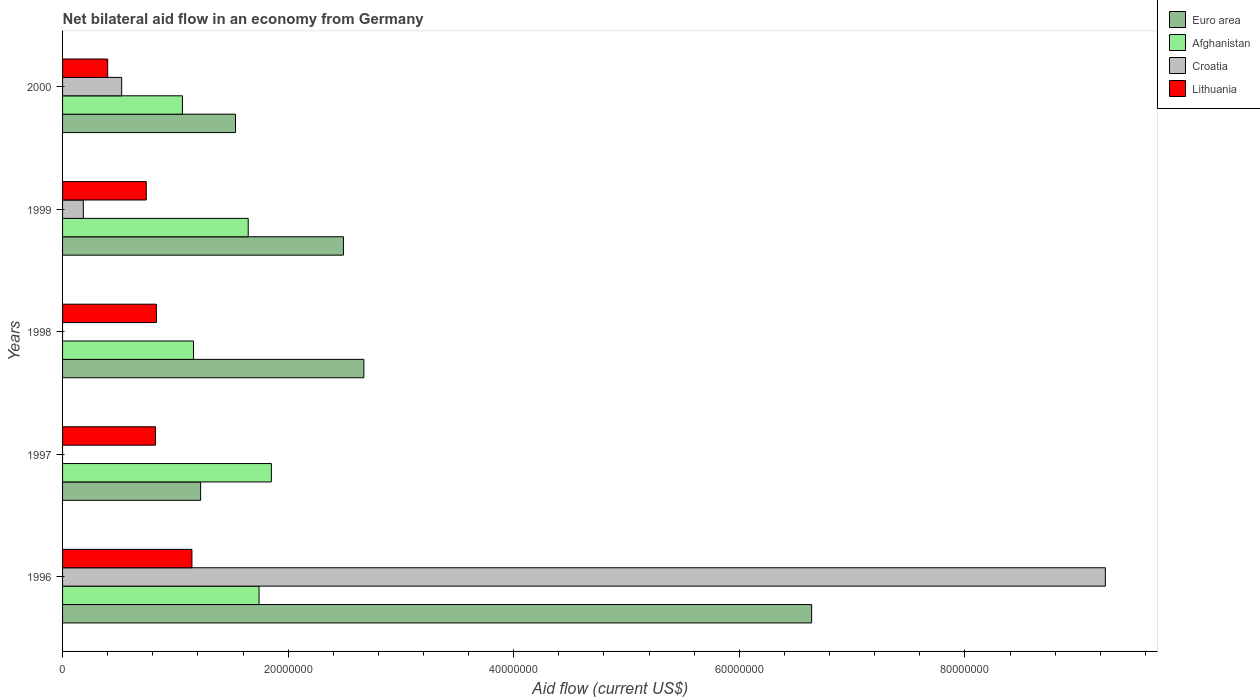How many groups of bars are there?
Offer a very short reply. 5. Are the number of bars per tick equal to the number of legend labels?
Provide a short and direct response. No. Are the number of bars on each tick of the Y-axis equal?
Your answer should be compact. No. How many bars are there on the 4th tick from the top?
Offer a terse response. 3. What is the label of the 5th group of bars from the top?
Keep it short and to the point. 1996. In how many cases, is the number of bars for a given year not equal to the number of legend labels?
Ensure brevity in your answer.  2. What is the net bilateral aid flow in Croatia in 2000?
Your answer should be very brief. 5.24e+06. Across all years, what is the maximum net bilateral aid flow in Afghanistan?
Offer a very short reply. 1.85e+07. Across all years, what is the minimum net bilateral aid flow in Euro area?
Provide a succinct answer. 1.22e+07. What is the total net bilateral aid flow in Afghanistan in the graph?
Provide a succinct answer. 7.46e+07. What is the difference between the net bilateral aid flow in Euro area in 1997 and that in 2000?
Provide a short and direct response. -3.09e+06. What is the difference between the net bilateral aid flow in Lithuania in 1996 and the net bilateral aid flow in Croatia in 1999?
Give a very brief answer. 9.63e+06. What is the average net bilateral aid flow in Afghanistan per year?
Your answer should be compact. 1.49e+07. In how many years, is the net bilateral aid flow in Afghanistan greater than 64000000 US$?
Offer a very short reply. 0. What is the ratio of the net bilateral aid flow in Lithuania in 1997 to that in 1998?
Your answer should be very brief. 0.99. What is the difference between the highest and the second highest net bilateral aid flow in Croatia?
Your answer should be compact. 8.72e+07. What is the difference between the highest and the lowest net bilateral aid flow in Afghanistan?
Your response must be concise. 7.88e+06. In how many years, is the net bilateral aid flow in Croatia greater than the average net bilateral aid flow in Croatia taken over all years?
Offer a terse response. 1. Is the sum of the net bilateral aid flow in Lithuania in 1998 and 2000 greater than the maximum net bilateral aid flow in Croatia across all years?
Give a very brief answer. No. Is it the case that in every year, the sum of the net bilateral aid flow in Euro area and net bilateral aid flow in Lithuania is greater than the net bilateral aid flow in Afghanistan?
Your answer should be compact. Yes. Are all the bars in the graph horizontal?
Offer a very short reply. Yes. How many years are there in the graph?
Your response must be concise. 5. Does the graph contain any zero values?
Provide a succinct answer. Yes. Does the graph contain grids?
Offer a very short reply. No. What is the title of the graph?
Give a very brief answer. Net bilateral aid flow in an economy from Germany. Does "Sub-Saharan Africa (developing only)" appear as one of the legend labels in the graph?
Provide a succinct answer. No. What is the Aid flow (current US$) of Euro area in 1996?
Your response must be concise. 6.64e+07. What is the Aid flow (current US$) of Afghanistan in 1996?
Give a very brief answer. 1.74e+07. What is the Aid flow (current US$) of Croatia in 1996?
Provide a succinct answer. 9.24e+07. What is the Aid flow (current US$) in Lithuania in 1996?
Make the answer very short. 1.15e+07. What is the Aid flow (current US$) of Euro area in 1997?
Your answer should be compact. 1.22e+07. What is the Aid flow (current US$) in Afghanistan in 1997?
Your answer should be compact. 1.85e+07. What is the Aid flow (current US$) of Lithuania in 1997?
Give a very brief answer. 8.24e+06. What is the Aid flow (current US$) in Euro area in 1998?
Offer a terse response. 2.67e+07. What is the Aid flow (current US$) in Afghanistan in 1998?
Your answer should be compact. 1.16e+07. What is the Aid flow (current US$) in Lithuania in 1998?
Your answer should be compact. 8.32e+06. What is the Aid flow (current US$) in Euro area in 1999?
Ensure brevity in your answer.  2.49e+07. What is the Aid flow (current US$) of Afghanistan in 1999?
Keep it short and to the point. 1.65e+07. What is the Aid flow (current US$) in Croatia in 1999?
Provide a succinct answer. 1.84e+06. What is the Aid flow (current US$) of Lithuania in 1999?
Provide a succinct answer. 7.42e+06. What is the Aid flow (current US$) in Euro area in 2000?
Ensure brevity in your answer.  1.53e+07. What is the Aid flow (current US$) in Afghanistan in 2000?
Provide a short and direct response. 1.06e+07. What is the Aid flow (current US$) in Croatia in 2000?
Your response must be concise. 5.24e+06. What is the Aid flow (current US$) in Lithuania in 2000?
Provide a succinct answer. 4.00e+06. Across all years, what is the maximum Aid flow (current US$) in Euro area?
Offer a very short reply. 6.64e+07. Across all years, what is the maximum Aid flow (current US$) of Afghanistan?
Provide a short and direct response. 1.85e+07. Across all years, what is the maximum Aid flow (current US$) of Croatia?
Offer a terse response. 9.24e+07. Across all years, what is the maximum Aid flow (current US$) in Lithuania?
Make the answer very short. 1.15e+07. Across all years, what is the minimum Aid flow (current US$) of Euro area?
Provide a short and direct response. 1.22e+07. Across all years, what is the minimum Aid flow (current US$) in Afghanistan?
Your response must be concise. 1.06e+07. Across all years, what is the minimum Aid flow (current US$) in Croatia?
Make the answer very short. 0. What is the total Aid flow (current US$) of Euro area in the graph?
Your response must be concise. 1.46e+08. What is the total Aid flow (current US$) of Afghanistan in the graph?
Give a very brief answer. 7.46e+07. What is the total Aid flow (current US$) in Croatia in the graph?
Provide a succinct answer. 9.95e+07. What is the total Aid flow (current US$) in Lithuania in the graph?
Keep it short and to the point. 3.94e+07. What is the difference between the Aid flow (current US$) of Euro area in 1996 and that in 1997?
Provide a short and direct response. 5.42e+07. What is the difference between the Aid flow (current US$) in Afghanistan in 1996 and that in 1997?
Keep it short and to the point. -1.09e+06. What is the difference between the Aid flow (current US$) of Lithuania in 1996 and that in 1997?
Ensure brevity in your answer.  3.23e+06. What is the difference between the Aid flow (current US$) of Euro area in 1996 and that in 1998?
Keep it short and to the point. 3.97e+07. What is the difference between the Aid flow (current US$) in Afghanistan in 1996 and that in 1998?
Your answer should be compact. 5.81e+06. What is the difference between the Aid flow (current US$) of Lithuania in 1996 and that in 1998?
Make the answer very short. 3.15e+06. What is the difference between the Aid flow (current US$) in Euro area in 1996 and that in 1999?
Offer a terse response. 4.15e+07. What is the difference between the Aid flow (current US$) in Afghanistan in 1996 and that in 1999?
Ensure brevity in your answer.  9.60e+05. What is the difference between the Aid flow (current US$) of Croatia in 1996 and that in 1999?
Your response must be concise. 9.06e+07. What is the difference between the Aid flow (current US$) in Lithuania in 1996 and that in 1999?
Give a very brief answer. 4.05e+06. What is the difference between the Aid flow (current US$) of Euro area in 1996 and that in 2000?
Keep it short and to the point. 5.11e+07. What is the difference between the Aid flow (current US$) of Afghanistan in 1996 and that in 2000?
Your response must be concise. 6.79e+06. What is the difference between the Aid flow (current US$) of Croatia in 1996 and that in 2000?
Your answer should be compact. 8.72e+07. What is the difference between the Aid flow (current US$) in Lithuania in 1996 and that in 2000?
Ensure brevity in your answer.  7.47e+06. What is the difference between the Aid flow (current US$) in Euro area in 1997 and that in 1998?
Offer a very short reply. -1.45e+07. What is the difference between the Aid flow (current US$) in Afghanistan in 1997 and that in 1998?
Make the answer very short. 6.90e+06. What is the difference between the Aid flow (current US$) in Lithuania in 1997 and that in 1998?
Ensure brevity in your answer.  -8.00e+04. What is the difference between the Aid flow (current US$) in Euro area in 1997 and that in 1999?
Provide a short and direct response. -1.27e+07. What is the difference between the Aid flow (current US$) of Afghanistan in 1997 and that in 1999?
Ensure brevity in your answer.  2.05e+06. What is the difference between the Aid flow (current US$) of Lithuania in 1997 and that in 1999?
Ensure brevity in your answer.  8.20e+05. What is the difference between the Aid flow (current US$) of Euro area in 1997 and that in 2000?
Offer a very short reply. -3.09e+06. What is the difference between the Aid flow (current US$) of Afghanistan in 1997 and that in 2000?
Keep it short and to the point. 7.88e+06. What is the difference between the Aid flow (current US$) in Lithuania in 1997 and that in 2000?
Ensure brevity in your answer.  4.24e+06. What is the difference between the Aid flow (current US$) in Euro area in 1998 and that in 1999?
Your response must be concise. 1.81e+06. What is the difference between the Aid flow (current US$) in Afghanistan in 1998 and that in 1999?
Your response must be concise. -4.85e+06. What is the difference between the Aid flow (current US$) of Euro area in 1998 and that in 2000?
Your answer should be compact. 1.14e+07. What is the difference between the Aid flow (current US$) in Afghanistan in 1998 and that in 2000?
Offer a very short reply. 9.80e+05. What is the difference between the Aid flow (current US$) in Lithuania in 1998 and that in 2000?
Make the answer very short. 4.32e+06. What is the difference between the Aid flow (current US$) of Euro area in 1999 and that in 2000?
Your response must be concise. 9.57e+06. What is the difference between the Aid flow (current US$) in Afghanistan in 1999 and that in 2000?
Your answer should be compact. 5.83e+06. What is the difference between the Aid flow (current US$) of Croatia in 1999 and that in 2000?
Make the answer very short. -3.40e+06. What is the difference between the Aid flow (current US$) of Lithuania in 1999 and that in 2000?
Your answer should be compact. 3.42e+06. What is the difference between the Aid flow (current US$) of Euro area in 1996 and the Aid flow (current US$) of Afghanistan in 1997?
Offer a very short reply. 4.79e+07. What is the difference between the Aid flow (current US$) of Euro area in 1996 and the Aid flow (current US$) of Lithuania in 1997?
Offer a terse response. 5.82e+07. What is the difference between the Aid flow (current US$) of Afghanistan in 1996 and the Aid flow (current US$) of Lithuania in 1997?
Your answer should be compact. 9.18e+06. What is the difference between the Aid flow (current US$) in Croatia in 1996 and the Aid flow (current US$) in Lithuania in 1997?
Keep it short and to the point. 8.42e+07. What is the difference between the Aid flow (current US$) in Euro area in 1996 and the Aid flow (current US$) in Afghanistan in 1998?
Offer a very short reply. 5.48e+07. What is the difference between the Aid flow (current US$) in Euro area in 1996 and the Aid flow (current US$) in Lithuania in 1998?
Provide a short and direct response. 5.81e+07. What is the difference between the Aid flow (current US$) in Afghanistan in 1996 and the Aid flow (current US$) in Lithuania in 1998?
Your answer should be very brief. 9.10e+06. What is the difference between the Aid flow (current US$) in Croatia in 1996 and the Aid flow (current US$) in Lithuania in 1998?
Offer a very short reply. 8.41e+07. What is the difference between the Aid flow (current US$) in Euro area in 1996 and the Aid flow (current US$) in Afghanistan in 1999?
Provide a succinct answer. 5.00e+07. What is the difference between the Aid flow (current US$) in Euro area in 1996 and the Aid flow (current US$) in Croatia in 1999?
Offer a very short reply. 6.46e+07. What is the difference between the Aid flow (current US$) in Euro area in 1996 and the Aid flow (current US$) in Lithuania in 1999?
Your response must be concise. 5.90e+07. What is the difference between the Aid flow (current US$) of Afghanistan in 1996 and the Aid flow (current US$) of Croatia in 1999?
Your answer should be very brief. 1.56e+07. What is the difference between the Aid flow (current US$) of Afghanistan in 1996 and the Aid flow (current US$) of Lithuania in 1999?
Ensure brevity in your answer.  1.00e+07. What is the difference between the Aid flow (current US$) of Croatia in 1996 and the Aid flow (current US$) of Lithuania in 1999?
Your answer should be compact. 8.50e+07. What is the difference between the Aid flow (current US$) of Euro area in 1996 and the Aid flow (current US$) of Afghanistan in 2000?
Your answer should be very brief. 5.58e+07. What is the difference between the Aid flow (current US$) of Euro area in 1996 and the Aid flow (current US$) of Croatia in 2000?
Offer a very short reply. 6.12e+07. What is the difference between the Aid flow (current US$) of Euro area in 1996 and the Aid flow (current US$) of Lithuania in 2000?
Ensure brevity in your answer.  6.24e+07. What is the difference between the Aid flow (current US$) in Afghanistan in 1996 and the Aid flow (current US$) in Croatia in 2000?
Offer a very short reply. 1.22e+07. What is the difference between the Aid flow (current US$) of Afghanistan in 1996 and the Aid flow (current US$) of Lithuania in 2000?
Provide a succinct answer. 1.34e+07. What is the difference between the Aid flow (current US$) in Croatia in 1996 and the Aid flow (current US$) in Lithuania in 2000?
Your response must be concise. 8.84e+07. What is the difference between the Aid flow (current US$) of Euro area in 1997 and the Aid flow (current US$) of Afghanistan in 1998?
Keep it short and to the point. 6.30e+05. What is the difference between the Aid flow (current US$) of Euro area in 1997 and the Aid flow (current US$) of Lithuania in 1998?
Ensure brevity in your answer.  3.92e+06. What is the difference between the Aid flow (current US$) in Afghanistan in 1997 and the Aid flow (current US$) in Lithuania in 1998?
Provide a succinct answer. 1.02e+07. What is the difference between the Aid flow (current US$) in Euro area in 1997 and the Aid flow (current US$) in Afghanistan in 1999?
Your answer should be compact. -4.22e+06. What is the difference between the Aid flow (current US$) of Euro area in 1997 and the Aid flow (current US$) of Croatia in 1999?
Give a very brief answer. 1.04e+07. What is the difference between the Aid flow (current US$) of Euro area in 1997 and the Aid flow (current US$) of Lithuania in 1999?
Make the answer very short. 4.82e+06. What is the difference between the Aid flow (current US$) in Afghanistan in 1997 and the Aid flow (current US$) in Croatia in 1999?
Provide a short and direct response. 1.67e+07. What is the difference between the Aid flow (current US$) in Afghanistan in 1997 and the Aid flow (current US$) in Lithuania in 1999?
Offer a very short reply. 1.11e+07. What is the difference between the Aid flow (current US$) in Euro area in 1997 and the Aid flow (current US$) in Afghanistan in 2000?
Offer a very short reply. 1.61e+06. What is the difference between the Aid flow (current US$) of Euro area in 1997 and the Aid flow (current US$) of Lithuania in 2000?
Keep it short and to the point. 8.24e+06. What is the difference between the Aid flow (current US$) in Afghanistan in 1997 and the Aid flow (current US$) in Croatia in 2000?
Give a very brief answer. 1.33e+07. What is the difference between the Aid flow (current US$) of Afghanistan in 1997 and the Aid flow (current US$) of Lithuania in 2000?
Make the answer very short. 1.45e+07. What is the difference between the Aid flow (current US$) in Euro area in 1998 and the Aid flow (current US$) in Afghanistan in 1999?
Keep it short and to the point. 1.02e+07. What is the difference between the Aid flow (current US$) in Euro area in 1998 and the Aid flow (current US$) in Croatia in 1999?
Ensure brevity in your answer.  2.49e+07. What is the difference between the Aid flow (current US$) of Euro area in 1998 and the Aid flow (current US$) of Lithuania in 1999?
Provide a succinct answer. 1.93e+07. What is the difference between the Aid flow (current US$) of Afghanistan in 1998 and the Aid flow (current US$) of Croatia in 1999?
Your answer should be compact. 9.77e+06. What is the difference between the Aid flow (current US$) in Afghanistan in 1998 and the Aid flow (current US$) in Lithuania in 1999?
Provide a short and direct response. 4.19e+06. What is the difference between the Aid flow (current US$) in Euro area in 1998 and the Aid flow (current US$) in Afghanistan in 2000?
Your response must be concise. 1.61e+07. What is the difference between the Aid flow (current US$) of Euro area in 1998 and the Aid flow (current US$) of Croatia in 2000?
Give a very brief answer. 2.15e+07. What is the difference between the Aid flow (current US$) of Euro area in 1998 and the Aid flow (current US$) of Lithuania in 2000?
Provide a succinct answer. 2.27e+07. What is the difference between the Aid flow (current US$) of Afghanistan in 1998 and the Aid flow (current US$) of Croatia in 2000?
Ensure brevity in your answer.  6.37e+06. What is the difference between the Aid flow (current US$) of Afghanistan in 1998 and the Aid flow (current US$) of Lithuania in 2000?
Give a very brief answer. 7.61e+06. What is the difference between the Aid flow (current US$) of Euro area in 1999 and the Aid flow (current US$) of Afghanistan in 2000?
Offer a terse response. 1.43e+07. What is the difference between the Aid flow (current US$) of Euro area in 1999 and the Aid flow (current US$) of Croatia in 2000?
Your response must be concise. 1.97e+07. What is the difference between the Aid flow (current US$) in Euro area in 1999 and the Aid flow (current US$) in Lithuania in 2000?
Ensure brevity in your answer.  2.09e+07. What is the difference between the Aid flow (current US$) of Afghanistan in 1999 and the Aid flow (current US$) of Croatia in 2000?
Provide a short and direct response. 1.12e+07. What is the difference between the Aid flow (current US$) of Afghanistan in 1999 and the Aid flow (current US$) of Lithuania in 2000?
Offer a very short reply. 1.25e+07. What is the difference between the Aid flow (current US$) in Croatia in 1999 and the Aid flow (current US$) in Lithuania in 2000?
Offer a terse response. -2.16e+06. What is the average Aid flow (current US$) of Euro area per year?
Provide a succinct answer. 2.91e+07. What is the average Aid flow (current US$) of Afghanistan per year?
Your response must be concise. 1.49e+07. What is the average Aid flow (current US$) of Croatia per year?
Make the answer very short. 1.99e+07. What is the average Aid flow (current US$) in Lithuania per year?
Offer a very short reply. 7.89e+06. In the year 1996, what is the difference between the Aid flow (current US$) in Euro area and Aid flow (current US$) in Afghanistan?
Your answer should be very brief. 4.90e+07. In the year 1996, what is the difference between the Aid flow (current US$) of Euro area and Aid flow (current US$) of Croatia?
Provide a short and direct response. -2.60e+07. In the year 1996, what is the difference between the Aid flow (current US$) in Euro area and Aid flow (current US$) in Lithuania?
Your answer should be very brief. 5.49e+07. In the year 1996, what is the difference between the Aid flow (current US$) of Afghanistan and Aid flow (current US$) of Croatia?
Offer a very short reply. -7.50e+07. In the year 1996, what is the difference between the Aid flow (current US$) in Afghanistan and Aid flow (current US$) in Lithuania?
Offer a very short reply. 5.95e+06. In the year 1996, what is the difference between the Aid flow (current US$) in Croatia and Aid flow (current US$) in Lithuania?
Make the answer very short. 8.10e+07. In the year 1997, what is the difference between the Aid flow (current US$) in Euro area and Aid flow (current US$) in Afghanistan?
Your answer should be compact. -6.27e+06. In the year 1997, what is the difference between the Aid flow (current US$) in Euro area and Aid flow (current US$) in Lithuania?
Provide a short and direct response. 4.00e+06. In the year 1997, what is the difference between the Aid flow (current US$) in Afghanistan and Aid flow (current US$) in Lithuania?
Ensure brevity in your answer.  1.03e+07. In the year 1998, what is the difference between the Aid flow (current US$) of Euro area and Aid flow (current US$) of Afghanistan?
Your answer should be very brief. 1.51e+07. In the year 1998, what is the difference between the Aid flow (current US$) of Euro area and Aid flow (current US$) of Lithuania?
Offer a terse response. 1.84e+07. In the year 1998, what is the difference between the Aid flow (current US$) in Afghanistan and Aid flow (current US$) in Lithuania?
Provide a short and direct response. 3.29e+06. In the year 1999, what is the difference between the Aid flow (current US$) in Euro area and Aid flow (current US$) in Afghanistan?
Offer a terse response. 8.44e+06. In the year 1999, what is the difference between the Aid flow (current US$) in Euro area and Aid flow (current US$) in Croatia?
Your response must be concise. 2.31e+07. In the year 1999, what is the difference between the Aid flow (current US$) of Euro area and Aid flow (current US$) of Lithuania?
Provide a short and direct response. 1.75e+07. In the year 1999, what is the difference between the Aid flow (current US$) in Afghanistan and Aid flow (current US$) in Croatia?
Give a very brief answer. 1.46e+07. In the year 1999, what is the difference between the Aid flow (current US$) of Afghanistan and Aid flow (current US$) of Lithuania?
Ensure brevity in your answer.  9.04e+06. In the year 1999, what is the difference between the Aid flow (current US$) of Croatia and Aid flow (current US$) of Lithuania?
Keep it short and to the point. -5.58e+06. In the year 2000, what is the difference between the Aid flow (current US$) in Euro area and Aid flow (current US$) in Afghanistan?
Make the answer very short. 4.70e+06. In the year 2000, what is the difference between the Aid flow (current US$) of Euro area and Aid flow (current US$) of Croatia?
Offer a very short reply. 1.01e+07. In the year 2000, what is the difference between the Aid flow (current US$) of Euro area and Aid flow (current US$) of Lithuania?
Give a very brief answer. 1.13e+07. In the year 2000, what is the difference between the Aid flow (current US$) in Afghanistan and Aid flow (current US$) in Croatia?
Make the answer very short. 5.39e+06. In the year 2000, what is the difference between the Aid flow (current US$) in Afghanistan and Aid flow (current US$) in Lithuania?
Provide a short and direct response. 6.63e+06. In the year 2000, what is the difference between the Aid flow (current US$) of Croatia and Aid flow (current US$) of Lithuania?
Your response must be concise. 1.24e+06. What is the ratio of the Aid flow (current US$) of Euro area in 1996 to that in 1997?
Your answer should be very brief. 5.43. What is the ratio of the Aid flow (current US$) of Afghanistan in 1996 to that in 1997?
Your response must be concise. 0.94. What is the ratio of the Aid flow (current US$) of Lithuania in 1996 to that in 1997?
Keep it short and to the point. 1.39. What is the ratio of the Aid flow (current US$) of Euro area in 1996 to that in 1998?
Your answer should be very brief. 2.49. What is the ratio of the Aid flow (current US$) of Afghanistan in 1996 to that in 1998?
Your response must be concise. 1.5. What is the ratio of the Aid flow (current US$) in Lithuania in 1996 to that in 1998?
Ensure brevity in your answer.  1.38. What is the ratio of the Aid flow (current US$) of Euro area in 1996 to that in 1999?
Your response must be concise. 2.67. What is the ratio of the Aid flow (current US$) in Afghanistan in 1996 to that in 1999?
Offer a terse response. 1.06. What is the ratio of the Aid flow (current US$) of Croatia in 1996 to that in 1999?
Provide a short and direct response. 50.24. What is the ratio of the Aid flow (current US$) of Lithuania in 1996 to that in 1999?
Offer a terse response. 1.55. What is the ratio of the Aid flow (current US$) in Euro area in 1996 to that in 2000?
Offer a terse response. 4.33. What is the ratio of the Aid flow (current US$) in Afghanistan in 1996 to that in 2000?
Give a very brief answer. 1.64. What is the ratio of the Aid flow (current US$) in Croatia in 1996 to that in 2000?
Offer a terse response. 17.64. What is the ratio of the Aid flow (current US$) of Lithuania in 1996 to that in 2000?
Make the answer very short. 2.87. What is the ratio of the Aid flow (current US$) of Euro area in 1997 to that in 1998?
Make the answer very short. 0.46. What is the ratio of the Aid flow (current US$) of Afghanistan in 1997 to that in 1998?
Your answer should be very brief. 1.59. What is the ratio of the Aid flow (current US$) of Euro area in 1997 to that in 1999?
Offer a very short reply. 0.49. What is the ratio of the Aid flow (current US$) of Afghanistan in 1997 to that in 1999?
Provide a short and direct response. 1.12. What is the ratio of the Aid flow (current US$) in Lithuania in 1997 to that in 1999?
Make the answer very short. 1.11. What is the ratio of the Aid flow (current US$) in Euro area in 1997 to that in 2000?
Ensure brevity in your answer.  0.8. What is the ratio of the Aid flow (current US$) of Afghanistan in 1997 to that in 2000?
Your response must be concise. 1.74. What is the ratio of the Aid flow (current US$) of Lithuania in 1997 to that in 2000?
Your answer should be very brief. 2.06. What is the ratio of the Aid flow (current US$) in Euro area in 1998 to that in 1999?
Provide a succinct answer. 1.07. What is the ratio of the Aid flow (current US$) in Afghanistan in 1998 to that in 1999?
Offer a terse response. 0.71. What is the ratio of the Aid flow (current US$) of Lithuania in 1998 to that in 1999?
Provide a succinct answer. 1.12. What is the ratio of the Aid flow (current US$) in Euro area in 1998 to that in 2000?
Offer a terse response. 1.74. What is the ratio of the Aid flow (current US$) of Afghanistan in 1998 to that in 2000?
Your answer should be very brief. 1.09. What is the ratio of the Aid flow (current US$) of Lithuania in 1998 to that in 2000?
Ensure brevity in your answer.  2.08. What is the ratio of the Aid flow (current US$) in Euro area in 1999 to that in 2000?
Give a very brief answer. 1.62. What is the ratio of the Aid flow (current US$) of Afghanistan in 1999 to that in 2000?
Your answer should be compact. 1.55. What is the ratio of the Aid flow (current US$) of Croatia in 1999 to that in 2000?
Give a very brief answer. 0.35. What is the ratio of the Aid flow (current US$) in Lithuania in 1999 to that in 2000?
Keep it short and to the point. 1.85. What is the difference between the highest and the second highest Aid flow (current US$) in Euro area?
Your answer should be very brief. 3.97e+07. What is the difference between the highest and the second highest Aid flow (current US$) of Afghanistan?
Provide a short and direct response. 1.09e+06. What is the difference between the highest and the second highest Aid flow (current US$) in Croatia?
Your answer should be very brief. 8.72e+07. What is the difference between the highest and the second highest Aid flow (current US$) in Lithuania?
Provide a succinct answer. 3.15e+06. What is the difference between the highest and the lowest Aid flow (current US$) of Euro area?
Ensure brevity in your answer.  5.42e+07. What is the difference between the highest and the lowest Aid flow (current US$) of Afghanistan?
Offer a very short reply. 7.88e+06. What is the difference between the highest and the lowest Aid flow (current US$) of Croatia?
Keep it short and to the point. 9.24e+07. What is the difference between the highest and the lowest Aid flow (current US$) of Lithuania?
Offer a terse response. 7.47e+06. 